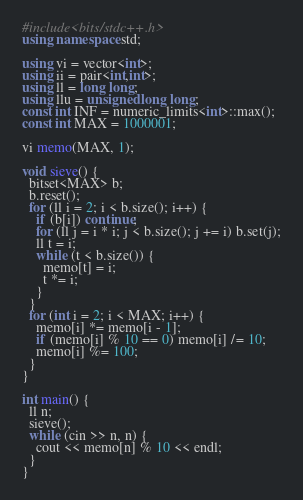Convert code to text. <code><loc_0><loc_0><loc_500><loc_500><_C++_>#include<bits/stdc++.h>
using namespace std;

using vi = vector<int>;
using ii = pair<int,int>;
using ll = long long;
using llu = unsigned long long;
const int INF = numeric_limits<int>::max();
const int MAX = 1000001;

vi memo(MAX, 1);

void sieve() {
  bitset<MAX> b;
  b.reset();
  for (ll i = 2; i < b.size(); i++) {
    if (b[i]) continue;
    for (ll j = i * i; j < b.size(); j += i) b.set(j);
    ll t = i;
    while (t < b.size()) {
      memo[t] = i;
      t *= i;
    }
  }
  for (int i = 2; i < MAX; i++) {
    memo[i] *= memo[i - 1];
    if (memo[i] % 10 == 0) memo[i] /= 10;
    memo[i] %= 100;
  }
}

int main() {
  ll n;
  sieve();
  while (cin >> n, n) {
    cout << memo[n] % 10 << endl;
  }
}
</code> 